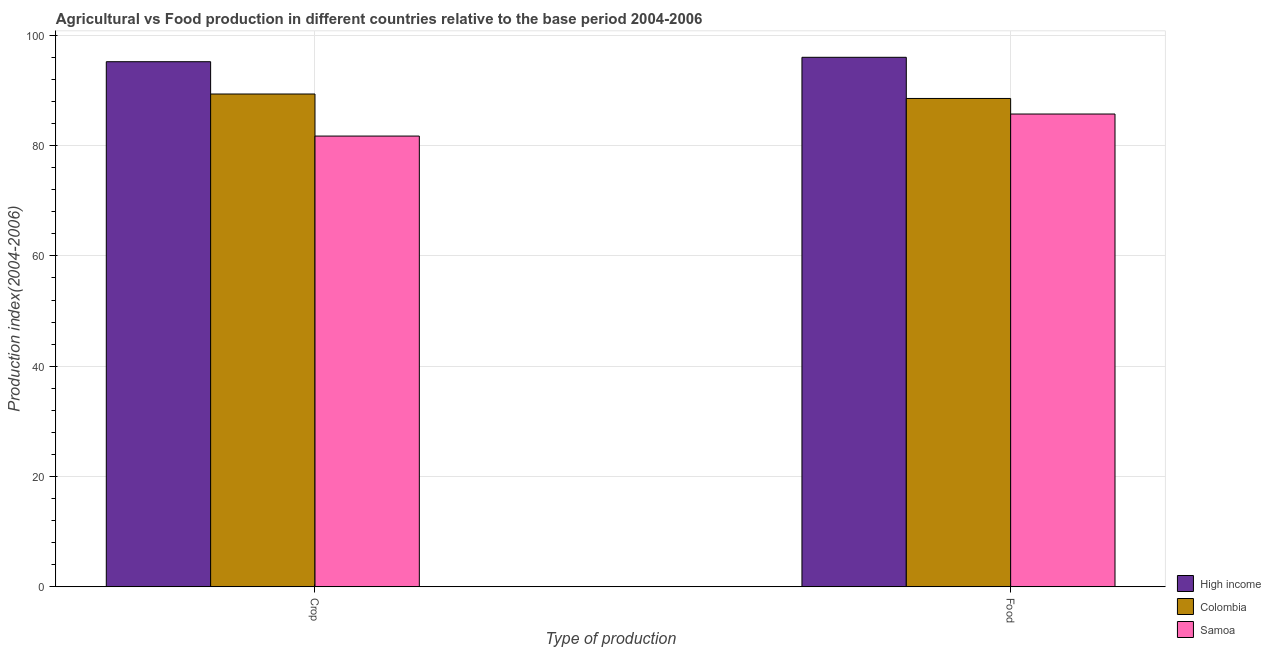Are the number of bars per tick equal to the number of legend labels?
Your answer should be very brief. Yes. Are the number of bars on each tick of the X-axis equal?
Provide a succinct answer. Yes. How many bars are there on the 1st tick from the right?
Offer a terse response. 3. What is the label of the 1st group of bars from the left?
Offer a terse response. Crop. What is the food production index in High income?
Provide a short and direct response. 96.03. Across all countries, what is the maximum food production index?
Your answer should be compact. 96.03. Across all countries, what is the minimum crop production index?
Your answer should be very brief. 81.74. In which country was the food production index maximum?
Make the answer very short. High income. In which country was the food production index minimum?
Provide a succinct answer. Samoa. What is the total crop production index in the graph?
Keep it short and to the point. 266.34. What is the difference between the crop production index in Samoa and that in High income?
Your answer should be compact. -13.49. What is the difference between the food production index in High income and the crop production index in Samoa?
Provide a succinct answer. 14.29. What is the average crop production index per country?
Provide a short and direct response. 88.78. What is the difference between the food production index and crop production index in High income?
Offer a terse response. 0.8. In how many countries, is the crop production index greater than 40 ?
Your answer should be very brief. 3. What is the ratio of the food production index in High income to that in Samoa?
Give a very brief answer. 1.12. Is the food production index in High income less than that in Samoa?
Your answer should be compact. No. What does the 3rd bar from the left in Crop represents?
Offer a terse response. Samoa. How many countries are there in the graph?
Provide a short and direct response. 3. What is the difference between two consecutive major ticks on the Y-axis?
Give a very brief answer. 20. Are the values on the major ticks of Y-axis written in scientific E-notation?
Offer a terse response. No. Does the graph contain grids?
Your response must be concise. Yes. How many legend labels are there?
Your response must be concise. 3. What is the title of the graph?
Make the answer very short. Agricultural vs Food production in different countries relative to the base period 2004-2006. Does "Bahrain" appear as one of the legend labels in the graph?
Your response must be concise. No. What is the label or title of the X-axis?
Offer a very short reply. Type of production. What is the label or title of the Y-axis?
Offer a very short reply. Production index(2004-2006). What is the Production index(2004-2006) of High income in Crop?
Keep it short and to the point. 95.23. What is the Production index(2004-2006) of Colombia in Crop?
Make the answer very short. 89.37. What is the Production index(2004-2006) in Samoa in Crop?
Give a very brief answer. 81.74. What is the Production index(2004-2006) of High income in Food?
Your answer should be very brief. 96.03. What is the Production index(2004-2006) in Colombia in Food?
Keep it short and to the point. 88.56. What is the Production index(2004-2006) in Samoa in Food?
Your answer should be very brief. 85.74. Across all Type of production, what is the maximum Production index(2004-2006) of High income?
Give a very brief answer. 96.03. Across all Type of production, what is the maximum Production index(2004-2006) in Colombia?
Your answer should be compact. 89.37. Across all Type of production, what is the maximum Production index(2004-2006) in Samoa?
Make the answer very short. 85.74. Across all Type of production, what is the minimum Production index(2004-2006) in High income?
Your answer should be compact. 95.23. Across all Type of production, what is the minimum Production index(2004-2006) in Colombia?
Your response must be concise. 88.56. Across all Type of production, what is the minimum Production index(2004-2006) of Samoa?
Make the answer very short. 81.74. What is the total Production index(2004-2006) of High income in the graph?
Offer a terse response. 191.25. What is the total Production index(2004-2006) of Colombia in the graph?
Keep it short and to the point. 177.93. What is the total Production index(2004-2006) in Samoa in the graph?
Keep it short and to the point. 167.48. What is the difference between the Production index(2004-2006) in High income in Crop and that in Food?
Your answer should be very brief. -0.8. What is the difference between the Production index(2004-2006) in Colombia in Crop and that in Food?
Provide a short and direct response. 0.81. What is the difference between the Production index(2004-2006) in Samoa in Crop and that in Food?
Your response must be concise. -4. What is the difference between the Production index(2004-2006) in High income in Crop and the Production index(2004-2006) in Colombia in Food?
Your answer should be very brief. 6.67. What is the difference between the Production index(2004-2006) of High income in Crop and the Production index(2004-2006) of Samoa in Food?
Provide a short and direct response. 9.49. What is the difference between the Production index(2004-2006) of Colombia in Crop and the Production index(2004-2006) of Samoa in Food?
Make the answer very short. 3.63. What is the average Production index(2004-2006) of High income per Type of production?
Your response must be concise. 95.63. What is the average Production index(2004-2006) of Colombia per Type of production?
Make the answer very short. 88.97. What is the average Production index(2004-2006) of Samoa per Type of production?
Make the answer very short. 83.74. What is the difference between the Production index(2004-2006) in High income and Production index(2004-2006) in Colombia in Crop?
Keep it short and to the point. 5.86. What is the difference between the Production index(2004-2006) of High income and Production index(2004-2006) of Samoa in Crop?
Your response must be concise. 13.49. What is the difference between the Production index(2004-2006) in Colombia and Production index(2004-2006) in Samoa in Crop?
Give a very brief answer. 7.63. What is the difference between the Production index(2004-2006) of High income and Production index(2004-2006) of Colombia in Food?
Make the answer very short. 7.47. What is the difference between the Production index(2004-2006) of High income and Production index(2004-2006) of Samoa in Food?
Ensure brevity in your answer.  10.29. What is the difference between the Production index(2004-2006) in Colombia and Production index(2004-2006) in Samoa in Food?
Make the answer very short. 2.82. What is the ratio of the Production index(2004-2006) in High income in Crop to that in Food?
Give a very brief answer. 0.99. What is the ratio of the Production index(2004-2006) of Colombia in Crop to that in Food?
Provide a short and direct response. 1.01. What is the ratio of the Production index(2004-2006) of Samoa in Crop to that in Food?
Give a very brief answer. 0.95. What is the difference between the highest and the second highest Production index(2004-2006) of High income?
Keep it short and to the point. 0.8. What is the difference between the highest and the second highest Production index(2004-2006) in Colombia?
Provide a short and direct response. 0.81. What is the difference between the highest and the lowest Production index(2004-2006) in High income?
Provide a succinct answer. 0.8. What is the difference between the highest and the lowest Production index(2004-2006) of Colombia?
Ensure brevity in your answer.  0.81. 